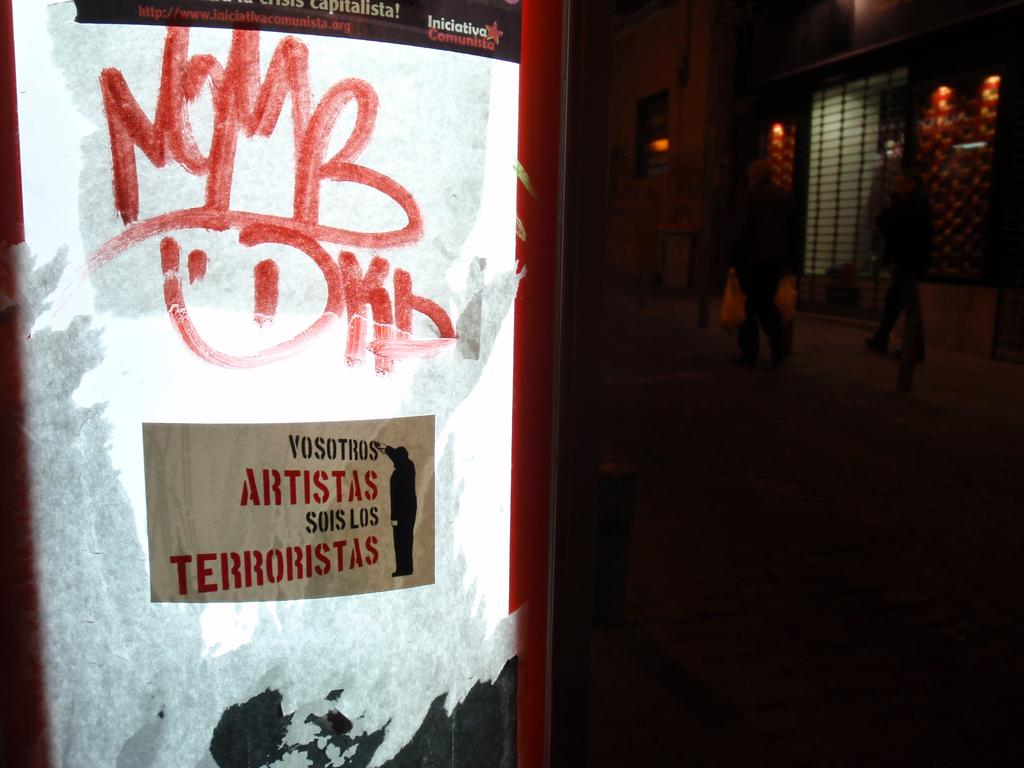<image>
Relay a brief, clear account of the picture shown. a a poster that has artistas written on it 